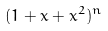Convert formula to latex. <formula><loc_0><loc_0><loc_500><loc_500>( 1 + x + x ^ { 2 } ) ^ { n }</formula> 